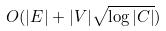Convert formula to latex. <formula><loc_0><loc_0><loc_500><loc_500>O ( | E | + | V | \sqrt { \log | C | } )</formula> 